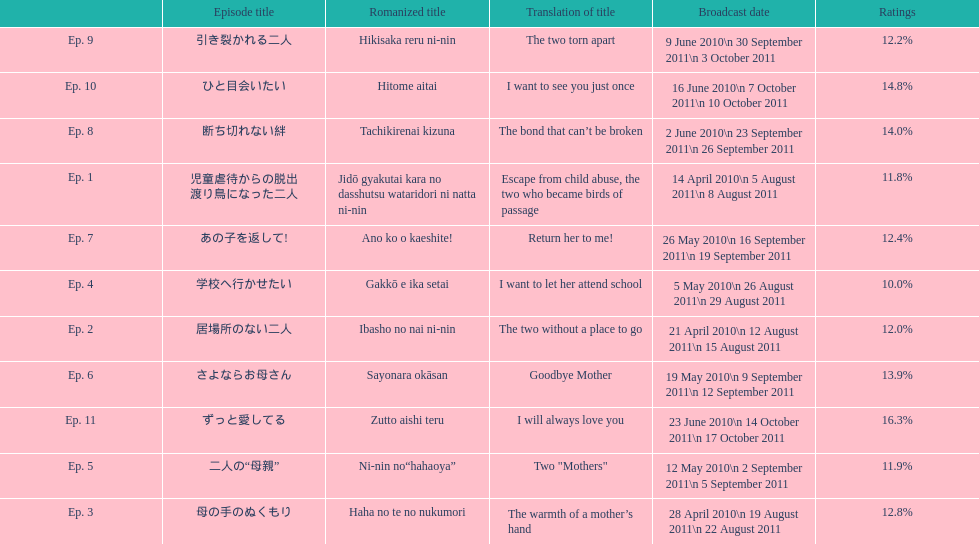Which episode was titled i want to let her attend school? Ep. 4. 